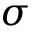<formula> <loc_0><loc_0><loc_500><loc_500>\sigma</formula> 